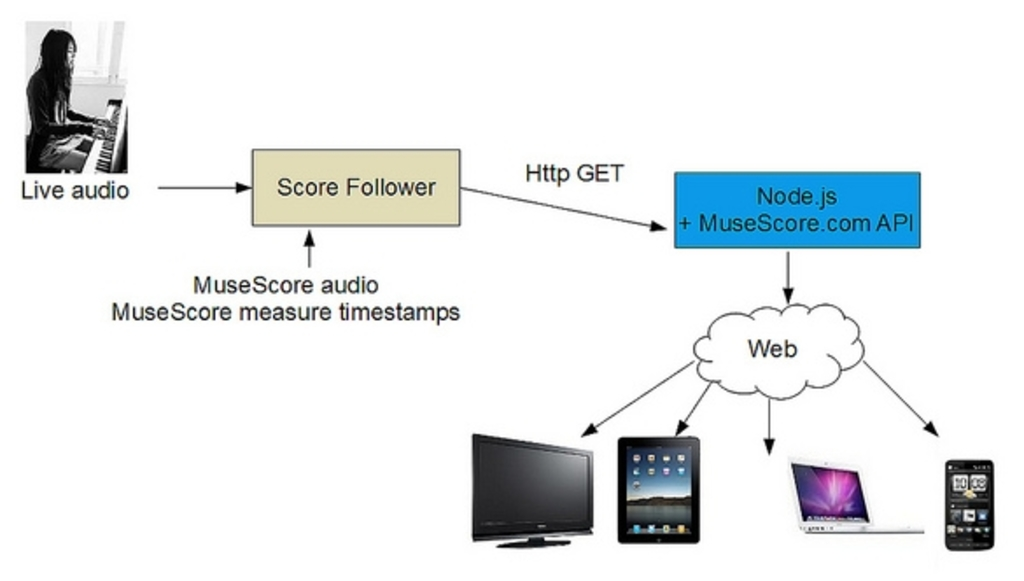What are the key elements in this picture? The image is a flowchart detailing the process by which live audio is processed and routed using MuseScore's functionalities. Starting from a live audio source, typically involving a piano or other instrumental input, the audio is first processed by the 'Score Follower.' This component synchronizes the live audio with MuseScore's measures and timestamps. Following this, the audio data is sent using an HTTP GET request to be processed by Node.js combined with the MuseScore.com API, effectively enabling the distribution of this synchronized audio to various platforms accessible via the web, including devices like laptops, tablets, and smartphones. This diagram efficiently illustrates the integration of audio technology with cloud computing to deliver a flexible and accessible music production and sharing system. 